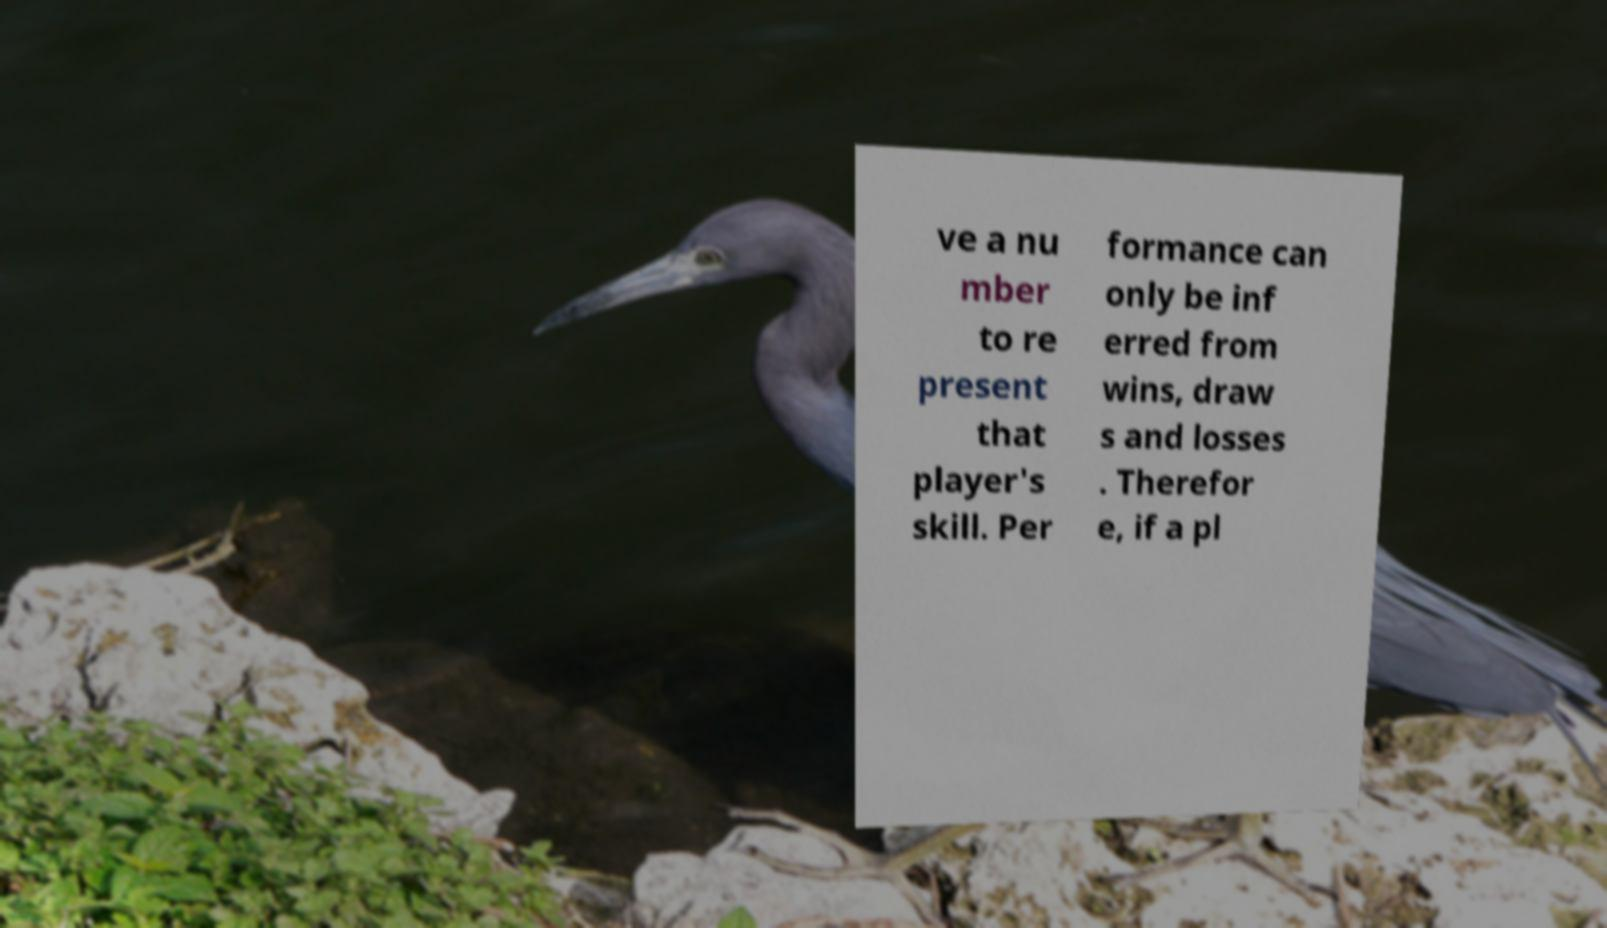There's text embedded in this image that I need extracted. Can you transcribe it verbatim? ve a nu mber to re present that player's skill. Per formance can only be inf erred from wins, draw s and losses . Therefor e, if a pl 